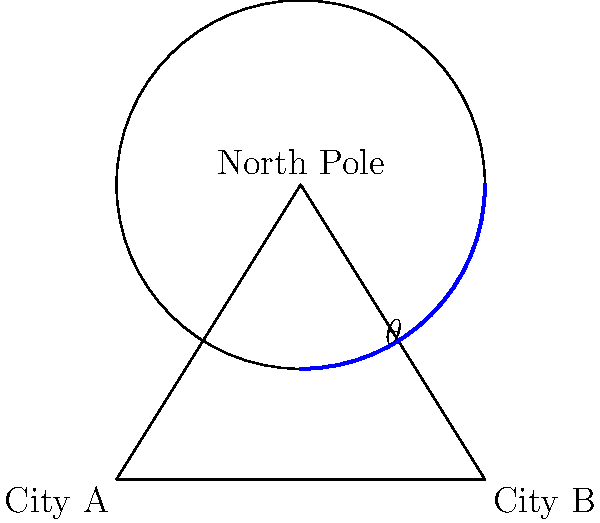As an airline executive, you're tasked with determining the most efficient flight path between two cities using great circle routes. Cities A and B are located on the same latitude, equidistant from the North Pole. The distance between the cities is 6000 km, and the radius of the Earth is approximately 6371 km. What is the central angle $\theta$ (in degrees) of the great circle arc between the two cities? To solve this problem, we'll use spherical trigonometry and the properties of great circles:

1) First, let's visualize the problem. The two cities and the North Pole form a spherical triangle on the surface of the Earth.

2) The line connecting the two cities forms the base of an isosceles triangle, with the North Pole at the apex.

3) We can use the formula for the central angle of a great circle arc:

   $$\theta = 2 \arcsin(\frac{d}{2R})$$

   Where $\theta$ is the central angle, $d$ is the distance between the cities, and $R$ is the radius of the Earth.

4) We're given:
   $d = 6000$ km
   $R = 6371$ km

5) Let's substitute these values into our formula:

   $$\theta = 2 \arcsin(\frac{6000}{2 * 6371})$$

6) Simplify:
   $$\theta = 2 \arcsin(0.4709)$$

7) Calculate:
   $$\theta = 2 * 28.1349°$$
   $$\theta = 56.2698°$$

8) Round to two decimal places:
   $$\theta \approx 56.27°$$

This angle represents the most efficient great circle route between the two cities.
Answer: 56.27° 